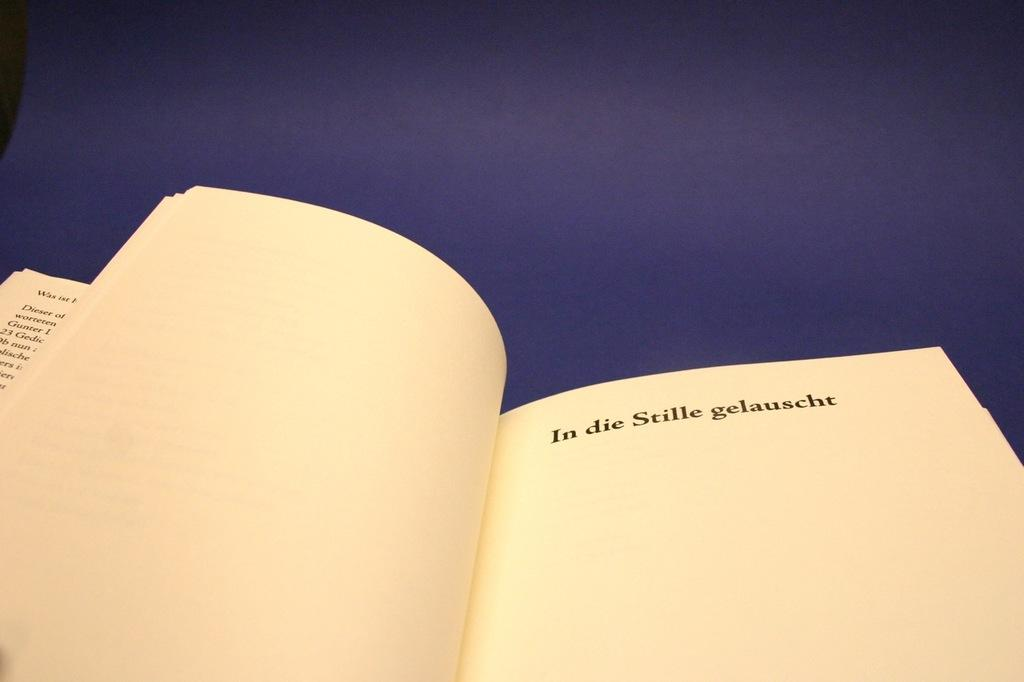<image>
Render a clear and concise summary of the photo. The phrase "In die Stille gelauscht" is printed on a book page. 